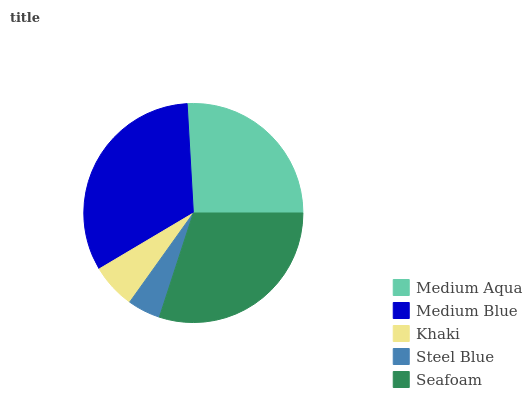Is Steel Blue the minimum?
Answer yes or no. Yes. Is Medium Blue the maximum?
Answer yes or no. Yes. Is Khaki the minimum?
Answer yes or no. No. Is Khaki the maximum?
Answer yes or no. No. Is Medium Blue greater than Khaki?
Answer yes or no. Yes. Is Khaki less than Medium Blue?
Answer yes or no. Yes. Is Khaki greater than Medium Blue?
Answer yes or no. No. Is Medium Blue less than Khaki?
Answer yes or no. No. Is Medium Aqua the high median?
Answer yes or no. Yes. Is Medium Aqua the low median?
Answer yes or no. Yes. Is Seafoam the high median?
Answer yes or no. No. Is Khaki the low median?
Answer yes or no. No. 